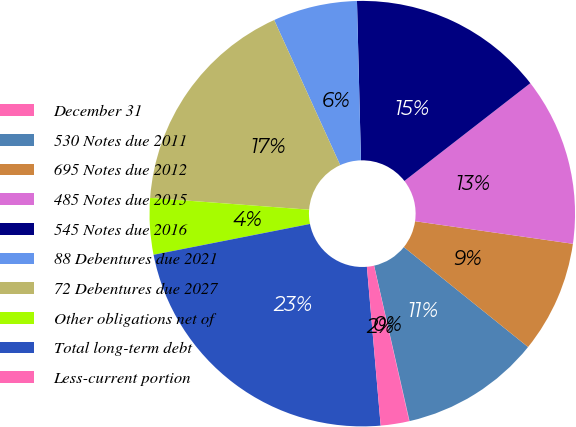<chart> <loc_0><loc_0><loc_500><loc_500><pie_chart><fcel>December 31<fcel>530 Notes due 2011<fcel>695 Notes due 2012<fcel>485 Notes due 2015<fcel>545 Notes due 2016<fcel>88 Debentures due 2021<fcel>72 Debentures due 2027<fcel>Other obligations net of<fcel>Total long-term debt<fcel>Less-current portion<nl><fcel>0.03%<fcel>10.65%<fcel>8.52%<fcel>12.77%<fcel>14.89%<fcel>6.4%<fcel>17.02%<fcel>4.28%<fcel>23.28%<fcel>2.16%<nl></chart> 